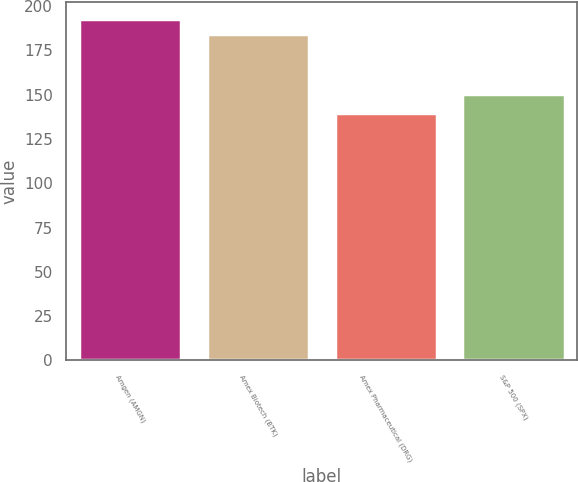Convert chart to OTSL. <chart><loc_0><loc_0><loc_500><loc_500><bar_chart><fcel>Amgen (AMGN)<fcel>Amex Biotech (BTK)<fcel>Amex Pharmaceutical (DRG)<fcel>S&P 500 (SPX)<nl><fcel>192.57<fcel>184.07<fcel>139.5<fcel>150.39<nl></chart> 